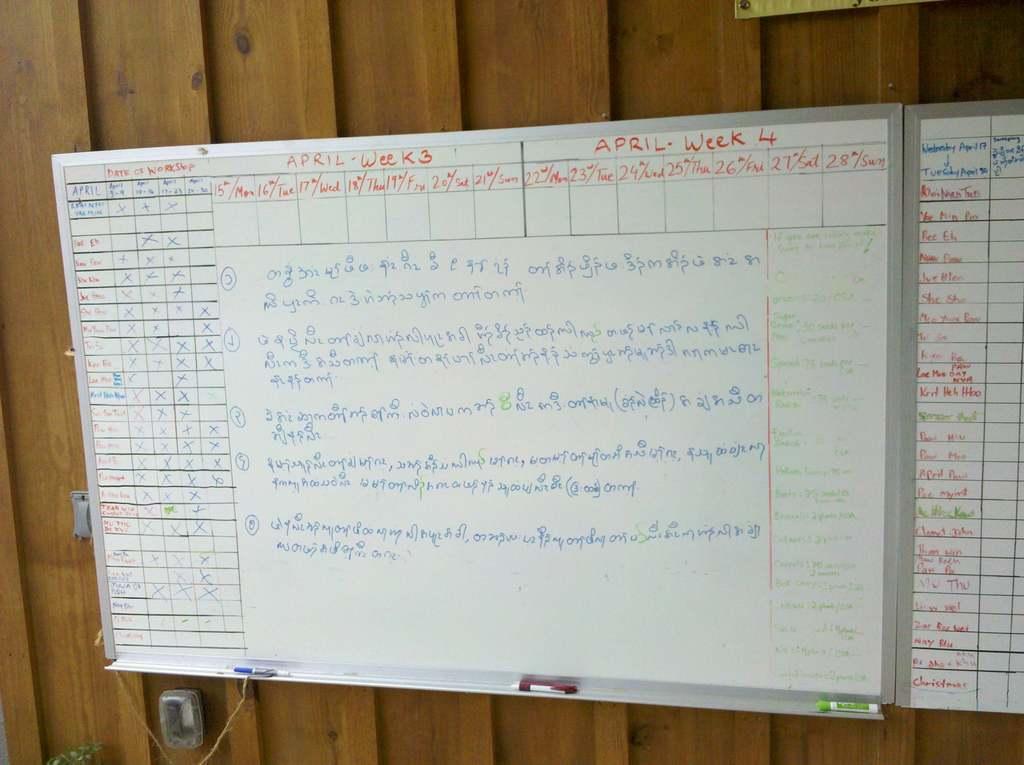What month is mentioned at the top?
Offer a very short reply. April. What two weeks are listed on top of board?
Provide a short and direct response. 3 and 4. 